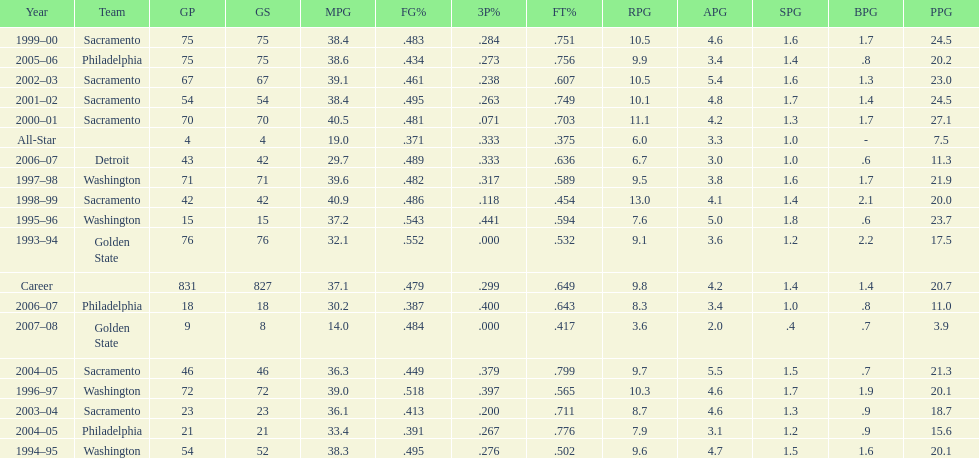How many seasons did webber average over 20 points per game (ppg)? 11. 